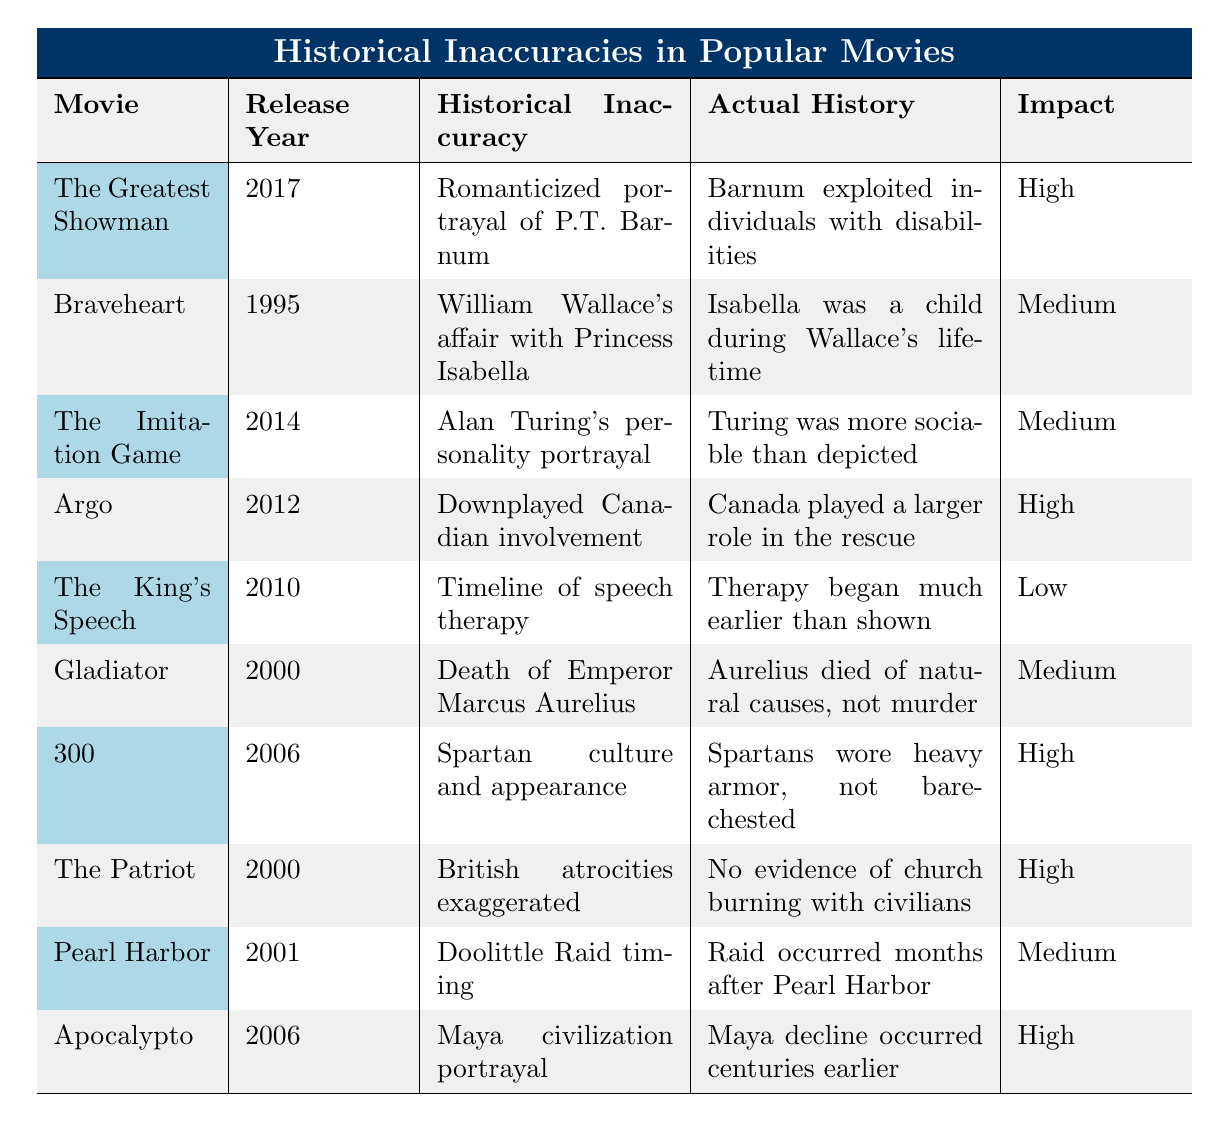What is the impact level of the movie "The Greatest Showman"? According to the table, "The Greatest Showman" has an impact level of "High" as stated in the last column.
Answer: High Which movie's historical inaccuracy is related to the Doolittle Raid? The table shows that "Pearl Harbor" has a historical inaccuracy related to the timing of the Doolittle Raid.
Answer: Pearl Harbor How many movies in the table have a "Medium" impact level? By counting the entries in the last column, there are three movies with a "Medium" impact level: "Braveheart," "The Imitation Game," and "Pearl Harbor."
Answer: 3 Is it true that the portrayal of Alan Turing in "The Imitation Game" is accurately represented? The table indicates that the portrayal of Alan Turing is inaccurate, as he was depicted as less sociable than he actually was.
Answer: No What year was "Argo" released, and what was its impact on perception? The table indicates that "Argo" was released in 2012 and had a "High" impact on perception.
Answer: 2012, High Which movie inaccurately romanticizes P.T. Barnum and what is the actual history? "The Greatest Showman" inaccurately romanticizes P.T. Barnum; the actual history notes that Barnum exploited individuals with disabilities.
Answer: The Greatest Showman; Barnum exploited individuals with disabilities How many movies feature historical inaccuracies with a "High" impact level? By checking the table, there are five movies with a "High" impact level: "The Greatest Showman," "Argo," "300," "The Patriot," and "Apocalypto."
Answer: 5 What is the correct portrayal of Spartan culture in the movie "300"? The table states that "300" inaccurately portrays Spartan culture and appearance, as Spartans wore heavy armor, not bare-chested.
Answer: Spartans wore heavy armor Which movie has a "Low" impact level and what was the historical inaccuracy related to it? The table lists "The King's Speech" as having a "Low" impact level, with the historical inaccuracy related to the timeline of speech therapy.
Answer: The King's Speech; Timeline of speech therapy What is the historical inaccuracy depicted in "The Imitation Game"? The inaccuracies in "The Imitation Game" relate to Alan Turing’s personality portrayal, showing him as less sociable than he actually was.
Answer: Alan Turing's personality portrayal If we count the total number of movies listed in the table, how many are there? The table lists a total of ten movies, as indicated by the number of entries provided.
Answer: 10 